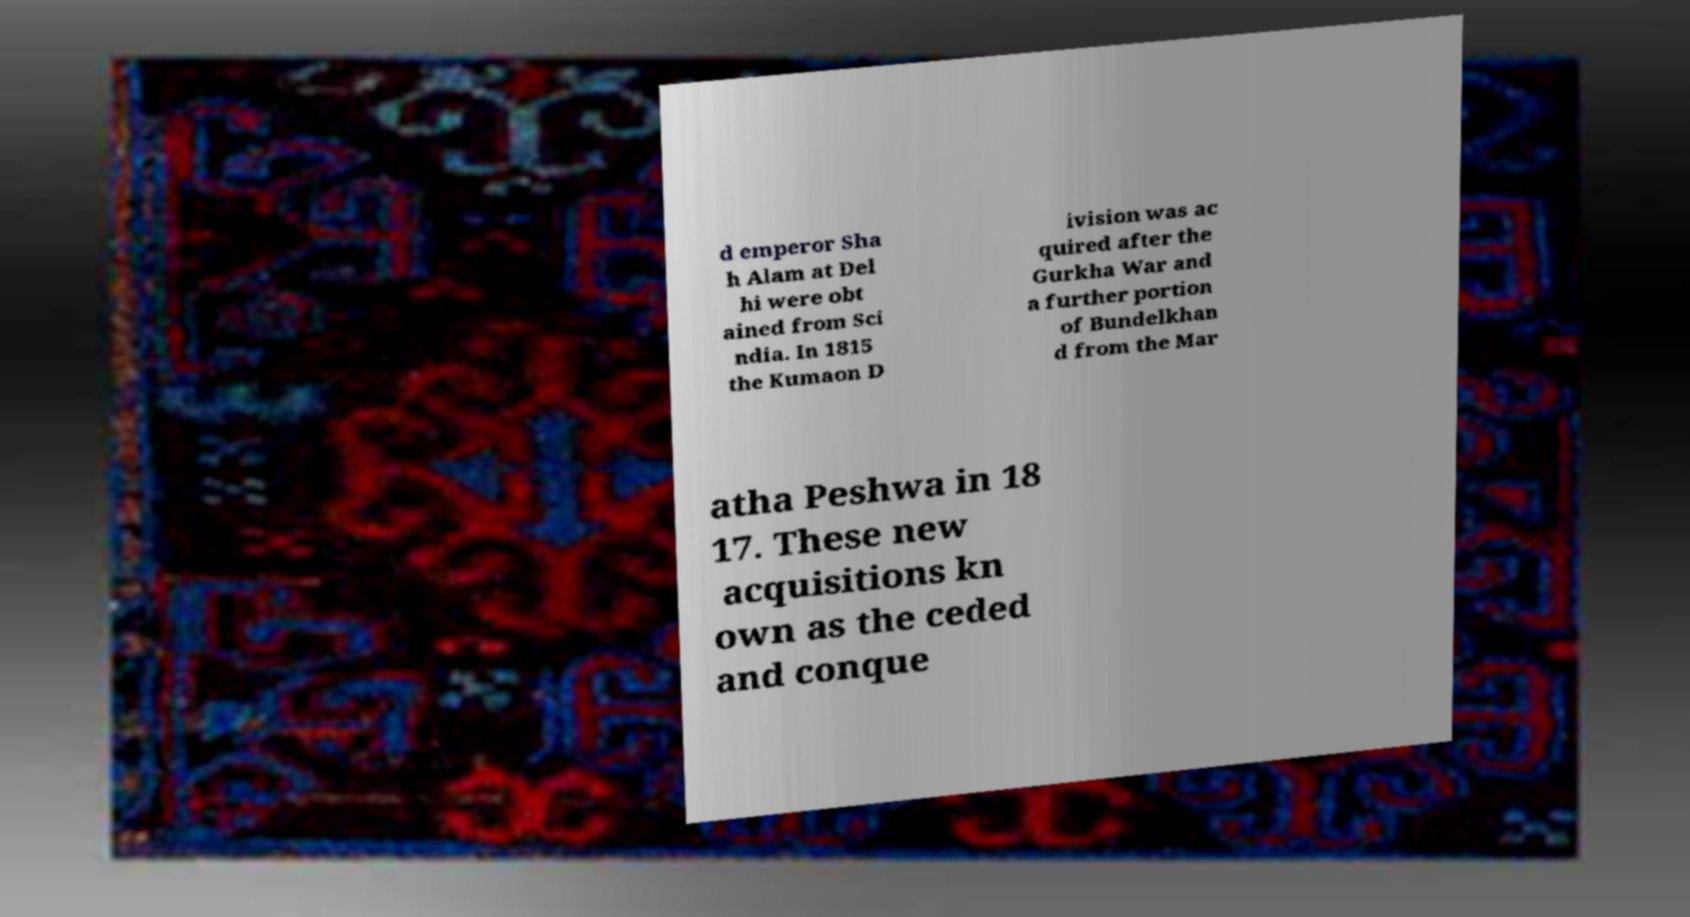Can you accurately transcribe the text from the provided image for me? d emperor Sha h Alam at Del hi were obt ained from Sci ndia. In 1815 the Kumaon D ivision was ac quired after the Gurkha War and a further portion of Bundelkhan d from the Mar atha Peshwa in 18 17. These new acquisitions kn own as the ceded and conque 